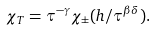Convert formula to latex. <formula><loc_0><loc_0><loc_500><loc_500>\chi _ { T } = \tau ^ { - \gamma } \chi _ { \pm } ( h / \tau ^ { \beta \delta } ) .</formula> 